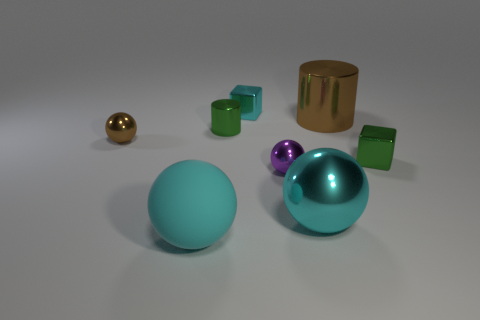Subtract all large rubber balls. How many balls are left? 3 Add 1 small metal cubes. How many objects exist? 9 Subtract all cyan cylinders. How many cyan spheres are left? 2 Subtract 1 blocks. How many blocks are left? 1 Subtract all purple balls. How many balls are left? 3 Subtract all gray cylinders. Subtract all brown cubes. How many cylinders are left? 2 Subtract all brown cubes. Subtract all large rubber objects. How many objects are left? 7 Add 3 small cylinders. How many small cylinders are left? 4 Add 6 rubber things. How many rubber things exist? 7 Subtract 0 yellow spheres. How many objects are left? 8 